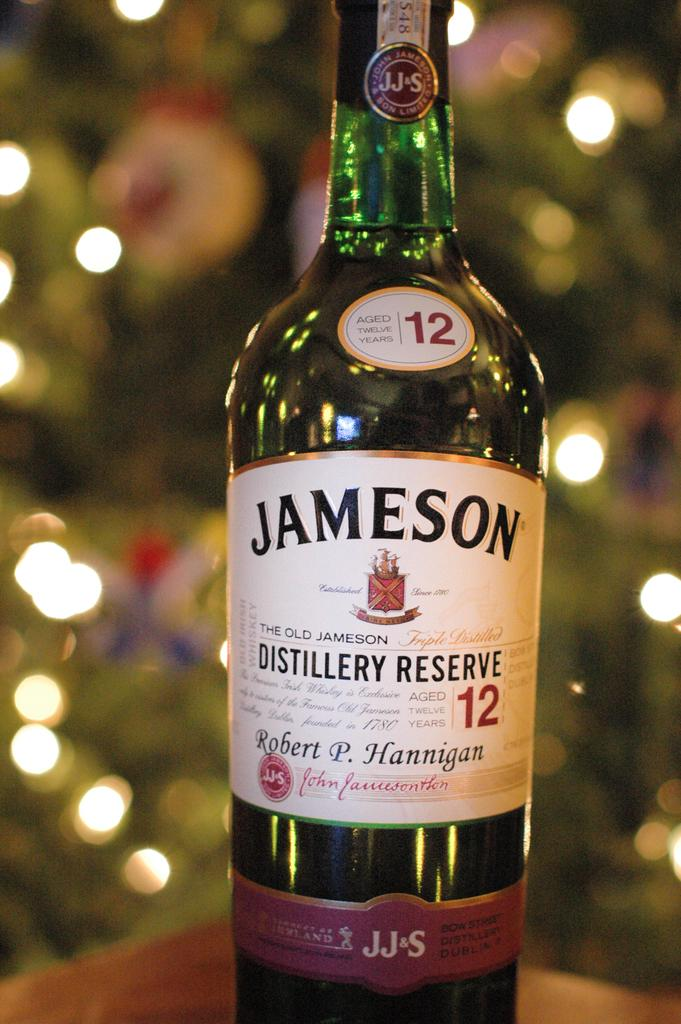<image>
Summarize the visual content of the image. Bottle of liquor with a white label that says Jameson on it. 